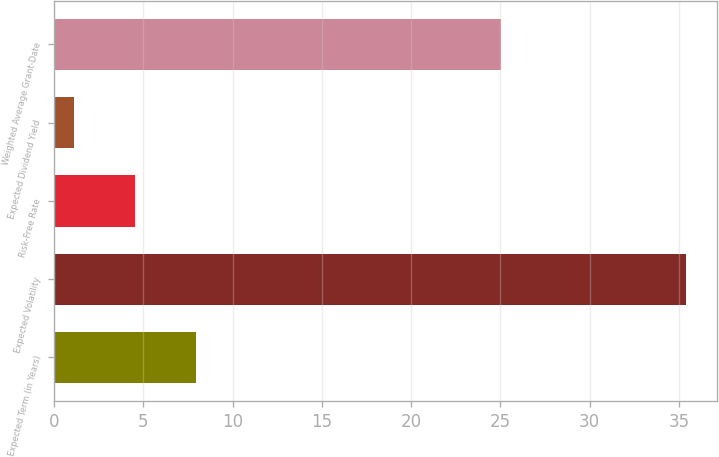Convert chart. <chart><loc_0><loc_0><loc_500><loc_500><bar_chart><fcel>Expected Term (in Years)<fcel>Expected Volatility<fcel>Risk-Free Rate<fcel>Expected Dividend Yield<fcel>Weighted Average Grant-Date<nl><fcel>7.96<fcel>35.4<fcel>4.53<fcel>1.1<fcel>25.05<nl></chart> 